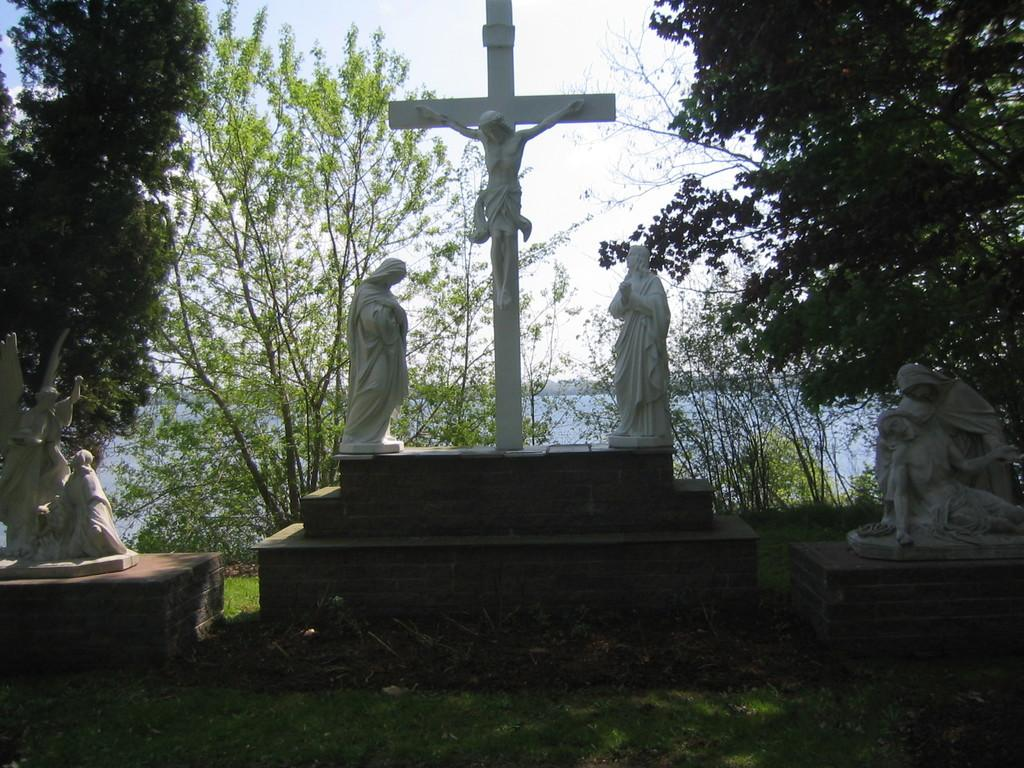What can be seen on the platforms in the image? There are statues on platforms in the image. What type of vegetation is present on the ground in the image? There is grass on the ground in the image. What can be seen in the background of the image? There are many trees and water visible in the background of the image, as well as the sky. What type of beam is holding up the trees in the image? There is no beam present in the image; the trees are standing on their own. 